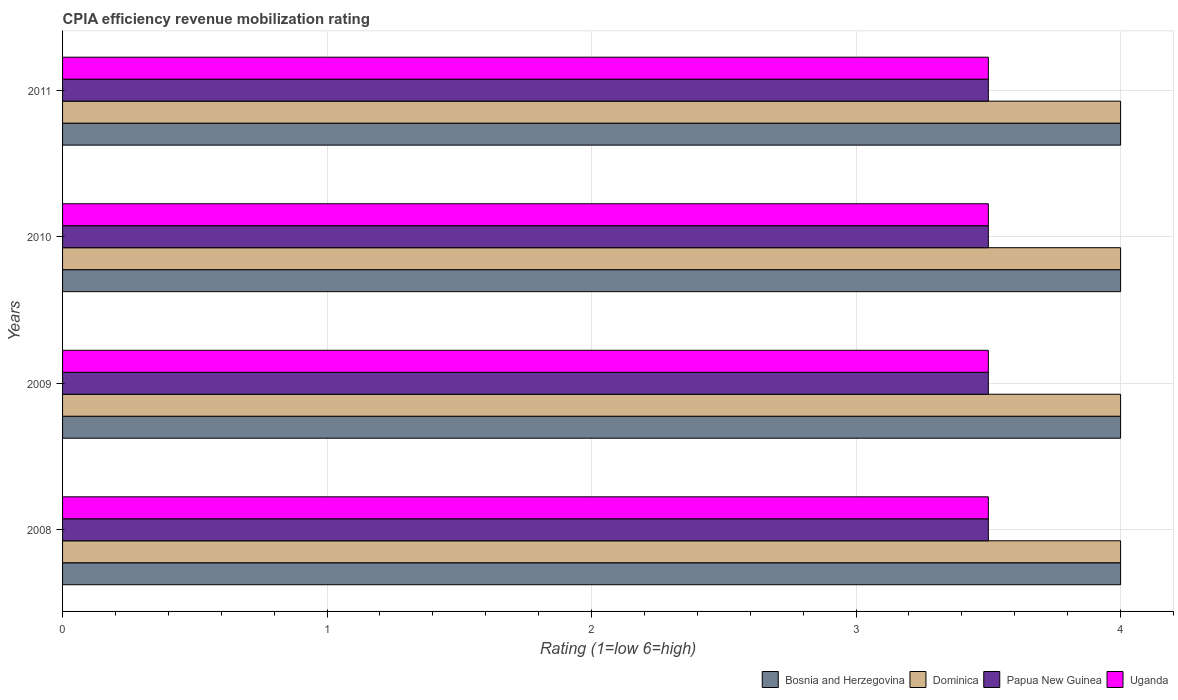How many groups of bars are there?
Give a very brief answer. 4. Are the number of bars on each tick of the Y-axis equal?
Keep it short and to the point. Yes. How many bars are there on the 2nd tick from the top?
Offer a terse response. 4. What is the label of the 4th group of bars from the top?
Ensure brevity in your answer.  2008. What is the total CPIA rating in Papua New Guinea in the graph?
Provide a succinct answer. 14. What is the difference between the CPIA rating in Bosnia and Herzegovina in 2008 and that in 2009?
Make the answer very short. 0. What is the difference between the CPIA rating in Uganda in 2009 and the CPIA rating in Dominica in 2008?
Make the answer very short. -0.5. What is the average CPIA rating in Papua New Guinea per year?
Your answer should be compact. 3.5. In how many years, is the CPIA rating in Uganda greater than 3.8 ?
Make the answer very short. 0. Is the difference between the CPIA rating in Uganda in 2008 and 2011 greater than the difference between the CPIA rating in Bosnia and Herzegovina in 2008 and 2011?
Provide a succinct answer. No. What is the difference between the highest and the lowest CPIA rating in Dominica?
Offer a very short reply. 0. What does the 4th bar from the top in 2010 represents?
Provide a succinct answer. Bosnia and Herzegovina. What does the 1st bar from the bottom in 2008 represents?
Your answer should be very brief. Bosnia and Herzegovina. Is it the case that in every year, the sum of the CPIA rating in Papua New Guinea and CPIA rating in Dominica is greater than the CPIA rating in Uganda?
Your answer should be compact. Yes. How many bars are there?
Offer a very short reply. 16. Are all the bars in the graph horizontal?
Provide a succinct answer. Yes. Does the graph contain grids?
Your response must be concise. Yes. How are the legend labels stacked?
Keep it short and to the point. Horizontal. What is the title of the graph?
Ensure brevity in your answer.  CPIA efficiency revenue mobilization rating. What is the Rating (1=low 6=high) of Bosnia and Herzegovina in 2009?
Give a very brief answer. 4. What is the Rating (1=low 6=high) of Dominica in 2009?
Make the answer very short. 4. What is the Rating (1=low 6=high) of Dominica in 2010?
Provide a short and direct response. 4. What is the Rating (1=low 6=high) of Bosnia and Herzegovina in 2011?
Make the answer very short. 4. What is the Rating (1=low 6=high) of Dominica in 2011?
Ensure brevity in your answer.  4. Across all years, what is the minimum Rating (1=low 6=high) in Bosnia and Herzegovina?
Keep it short and to the point. 4. What is the total Rating (1=low 6=high) of Papua New Guinea in the graph?
Give a very brief answer. 14. What is the difference between the Rating (1=low 6=high) of Bosnia and Herzegovina in 2008 and that in 2009?
Your answer should be very brief. 0. What is the difference between the Rating (1=low 6=high) in Papua New Guinea in 2008 and that in 2009?
Provide a succinct answer. 0. What is the difference between the Rating (1=low 6=high) in Uganda in 2008 and that in 2009?
Keep it short and to the point. 0. What is the difference between the Rating (1=low 6=high) of Bosnia and Herzegovina in 2008 and that in 2010?
Give a very brief answer. 0. What is the difference between the Rating (1=low 6=high) of Dominica in 2008 and that in 2010?
Provide a short and direct response. 0. What is the difference between the Rating (1=low 6=high) in Uganda in 2008 and that in 2010?
Provide a succinct answer. 0. What is the difference between the Rating (1=low 6=high) in Dominica in 2009 and that in 2011?
Your answer should be compact. 0. What is the difference between the Rating (1=low 6=high) in Papua New Guinea in 2009 and that in 2011?
Provide a succinct answer. 0. What is the difference between the Rating (1=low 6=high) of Uganda in 2009 and that in 2011?
Ensure brevity in your answer.  0. What is the difference between the Rating (1=low 6=high) in Dominica in 2010 and that in 2011?
Give a very brief answer. 0. What is the difference between the Rating (1=low 6=high) in Papua New Guinea in 2010 and that in 2011?
Offer a terse response. 0. What is the difference between the Rating (1=low 6=high) of Uganda in 2010 and that in 2011?
Offer a terse response. 0. What is the difference between the Rating (1=low 6=high) of Bosnia and Herzegovina in 2008 and the Rating (1=low 6=high) of Papua New Guinea in 2009?
Provide a short and direct response. 0.5. What is the difference between the Rating (1=low 6=high) in Bosnia and Herzegovina in 2008 and the Rating (1=low 6=high) in Uganda in 2009?
Your answer should be very brief. 0.5. What is the difference between the Rating (1=low 6=high) of Papua New Guinea in 2008 and the Rating (1=low 6=high) of Uganda in 2009?
Your response must be concise. 0. What is the difference between the Rating (1=low 6=high) of Bosnia and Herzegovina in 2008 and the Rating (1=low 6=high) of Uganda in 2010?
Your answer should be compact. 0.5. What is the difference between the Rating (1=low 6=high) of Dominica in 2008 and the Rating (1=low 6=high) of Papua New Guinea in 2010?
Your answer should be very brief. 0.5. What is the difference between the Rating (1=low 6=high) of Dominica in 2008 and the Rating (1=low 6=high) of Uganda in 2010?
Keep it short and to the point. 0.5. What is the difference between the Rating (1=low 6=high) of Papua New Guinea in 2008 and the Rating (1=low 6=high) of Uganda in 2010?
Your response must be concise. 0. What is the difference between the Rating (1=low 6=high) in Bosnia and Herzegovina in 2008 and the Rating (1=low 6=high) in Papua New Guinea in 2011?
Provide a succinct answer. 0.5. What is the difference between the Rating (1=low 6=high) in Dominica in 2008 and the Rating (1=low 6=high) in Papua New Guinea in 2011?
Provide a short and direct response. 0.5. What is the difference between the Rating (1=low 6=high) of Bosnia and Herzegovina in 2009 and the Rating (1=low 6=high) of Papua New Guinea in 2010?
Offer a very short reply. 0.5. What is the difference between the Rating (1=low 6=high) in Papua New Guinea in 2009 and the Rating (1=low 6=high) in Uganda in 2010?
Your response must be concise. 0. What is the difference between the Rating (1=low 6=high) in Bosnia and Herzegovina in 2009 and the Rating (1=low 6=high) in Papua New Guinea in 2011?
Make the answer very short. 0.5. What is the difference between the Rating (1=low 6=high) in Dominica in 2009 and the Rating (1=low 6=high) in Papua New Guinea in 2011?
Provide a short and direct response. 0.5. What is the difference between the Rating (1=low 6=high) of Dominica in 2009 and the Rating (1=low 6=high) of Uganda in 2011?
Give a very brief answer. 0.5. What is the difference between the Rating (1=low 6=high) of Bosnia and Herzegovina in 2010 and the Rating (1=low 6=high) of Dominica in 2011?
Keep it short and to the point. 0. What is the difference between the Rating (1=low 6=high) in Bosnia and Herzegovina in 2010 and the Rating (1=low 6=high) in Papua New Guinea in 2011?
Provide a short and direct response. 0.5. What is the difference between the Rating (1=low 6=high) in Dominica in 2010 and the Rating (1=low 6=high) in Uganda in 2011?
Your answer should be very brief. 0.5. What is the average Rating (1=low 6=high) of Dominica per year?
Ensure brevity in your answer.  4. What is the average Rating (1=low 6=high) in Papua New Guinea per year?
Keep it short and to the point. 3.5. In the year 2008, what is the difference between the Rating (1=low 6=high) in Bosnia and Herzegovina and Rating (1=low 6=high) in Dominica?
Provide a short and direct response. 0. In the year 2008, what is the difference between the Rating (1=low 6=high) in Dominica and Rating (1=low 6=high) in Papua New Guinea?
Keep it short and to the point. 0.5. In the year 2009, what is the difference between the Rating (1=low 6=high) in Bosnia and Herzegovina and Rating (1=low 6=high) in Papua New Guinea?
Ensure brevity in your answer.  0.5. In the year 2009, what is the difference between the Rating (1=low 6=high) in Bosnia and Herzegovina and Rating (1=low 6=high) in Uganda?
Offer a terse response. 0.5. In the year 2009, what is the difference between the Rating (1=low 6=high) of Dominica and Rating (1=low 6=high) of Papua New Guinea?
Offer a very short reply. 0.5. In the year 2009, what is the difference between the Rating (1=low 6=high) of Papua New Guinea and Rating (1=low 6=high) of Uganda?
Provide a short and direct response. 0. In the year 2010, what is the difference between the Rating (1=low 6=high) in Bosnia and Herzegovina and Rating (1=low 6=high) in Papua New Guinea?
Ensure brevity in your answer.  0.5. In the year 2010, what is the difference between the Rating (1=low 6=high) in Bosnia and Herzegovina and Rating (1=low 6=high) in Uganda?
Offer a very short reply. 0.5. In the year 2011, what is the difference between the Rating (1=low 6=high) of Bosnia and Herzegovina and Rating (1=low 6=high) of Papua New Guinea?
Make the answer very short. 0.5. In the year 2011, what is the difference between the Rating (1=low 6=high) in Papua New Guinea and Rating (1=low 6=high) in Uganda?
Offer a terse response. 0. What is the ratio of the Rating (1=low 6=high) in Dominica in 2008 to that in 2009?
Give a very brief answer. 1. What is the ratio of the Rating (1=low 6=high) in Uganda in 2008 to that in 2009?
Keep it short and to the point. 1. What is the ratio of the Rating (1=low 6=high) of Bosnia and Herzegovina in 2008 to that in 2010?
Give a very brief answer. 1. What is the ratio of the Rating (1=low 6=high) of Papua New Guinea in 2008 to that in 2010?
Keep it short and to the point. 1. What is the ratio of the Rating (1=low 6=high) of Bosnia and Herzegovina in 2008 to that in 2011?
Ensure brevity in your answer.  1. What is the ratio of the Rating (1=low 6=high) in Dominica in 2008 to that in 2011?
Your answer should be very brief. 1. What is the ratio of the Rating (1=low 6=high) in Uganda in 2009 to that in 2010?
Your answer should be compact. 1. What is the ratio of the Rating (1=low 6=high) of Dominica in 2009 to that in 2011?
Offer a very short reply. 1. What is the ratio of the Rating (1=low 6=high) in Dominica in 2010 to that in 2011?
Offer a very short reply. 1. What is the ratio of the Rating (1=low 6=high) of Uganda in 2010 to that in 2011?
Offer a terse response. 1. What is the difference between the highest and the second highest Rating (1=low 6=high) in Uganda?
Offer a terse response. 0. What is the difference between the highest and the lowest Rating (1=low 6=high) in Bosnia and Herzegovina?
Your response must be concise. 0. What is the difference between the highest and the lowest Rating (1=low 6=high) of Dominica?
Provide a short and direct response. 0. What is the difference between the highest and the lowest Rating (1=low 6=high) of Papua New Guinea?
Make the answer very short. 0. What is the difference between the highest and the lowest Rating (1=low 6=high) of Uganda?
Offer a very short reply. 0. 